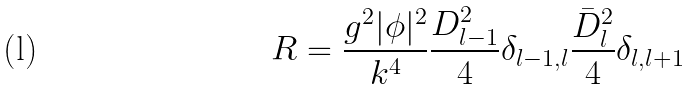<formula> <loc_0><loc_0><loc_500><loc_500>R = \frac { g ^ { 2 } | \phi | ^ { 2 } } { k ^ { 4 } } \frac { D ^ { 2 } _ { l - 1 } } { 4 } \delta _ { l - 1 , l } \frac { \bar { D } ^ { 2 } _ { l } } { 4 } \delta _ { l , l + 1 }</formula> 